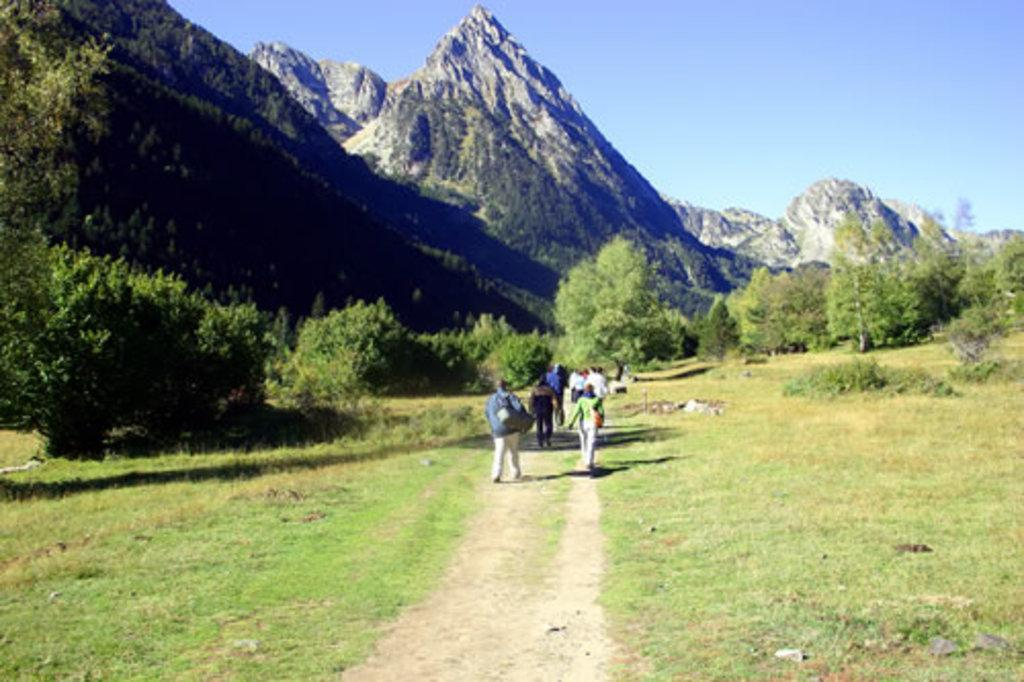What type of natural feature is on the left side of the image? There are mountains on the left side of the image. What else can be seen on the left side of the image? There are trees on the left side of the image. What are the people in the image doing? There are people walking on a grass path at the center of the image. What can be seen in the background of the image? There is a sky visible in the background of the image. Can you tell me how many brushes are being used by the people walking on the grass path? There is no mention of brushes in the image, so it cannot be determined how many, if any, are being used. 